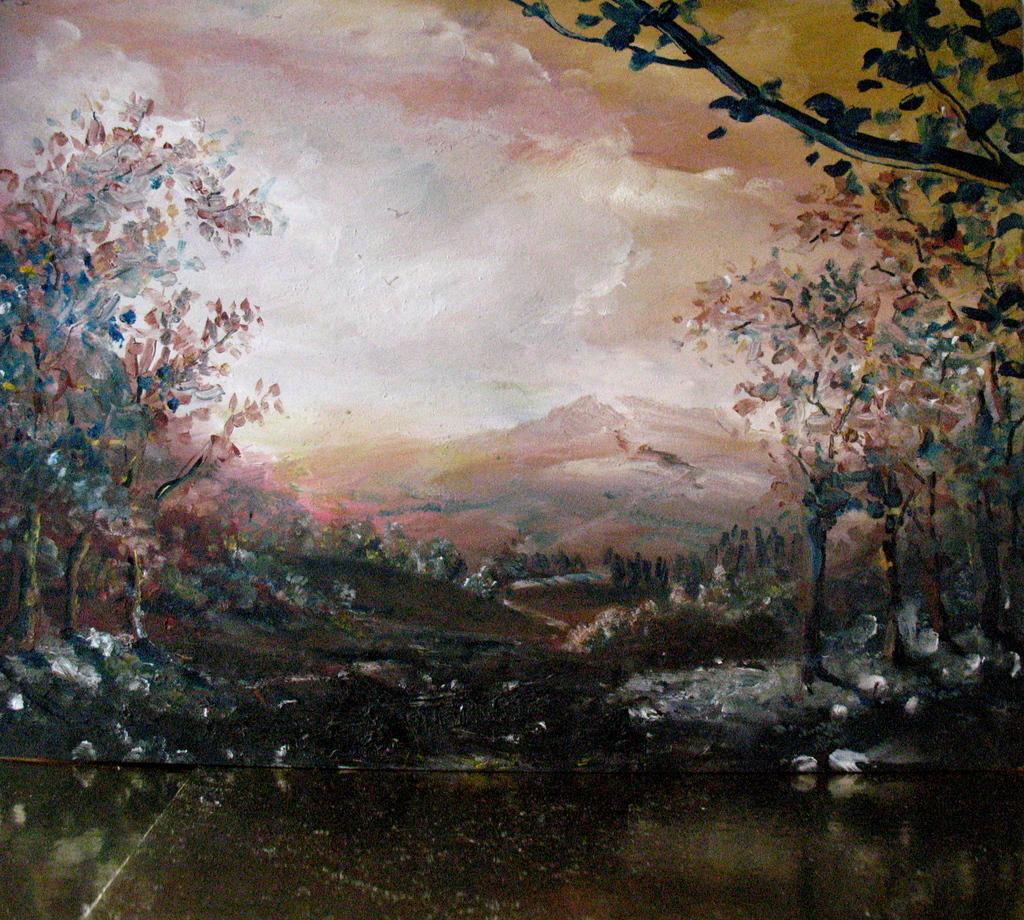What type of natural features can be seen in the image? There are trees and mountains in the image. What else is visible in the image besides the trees and mountains? There is water visible in the image. What type of art medium is the image? The image is a painting. Where is the flower located in the image? There is no flower present in the image. What type of rock can be seen near the water in the image? There is no rock visible in the image; only trees, mountains, and water are present. 